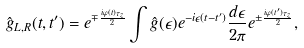<formula> <loc_0><loc_0><loc_500><loc_500>\hat { g } _ { L , R } ( t , t ^ { \prime } ) = e ^ { \mp \frac { i \varphi ( t ) \tau _ { z } } { 2 } } \int \hat { g } ( \epsilon ) e ^ { - i \epsilon ( t - t ^ { \prime } ) } \frac { d \epsilon } { 2 \pi } e ^ { \pm \frac { i \varphi ( t ^ { \prime } ) \tau _ { z } } { 2 } } ,</formula> 